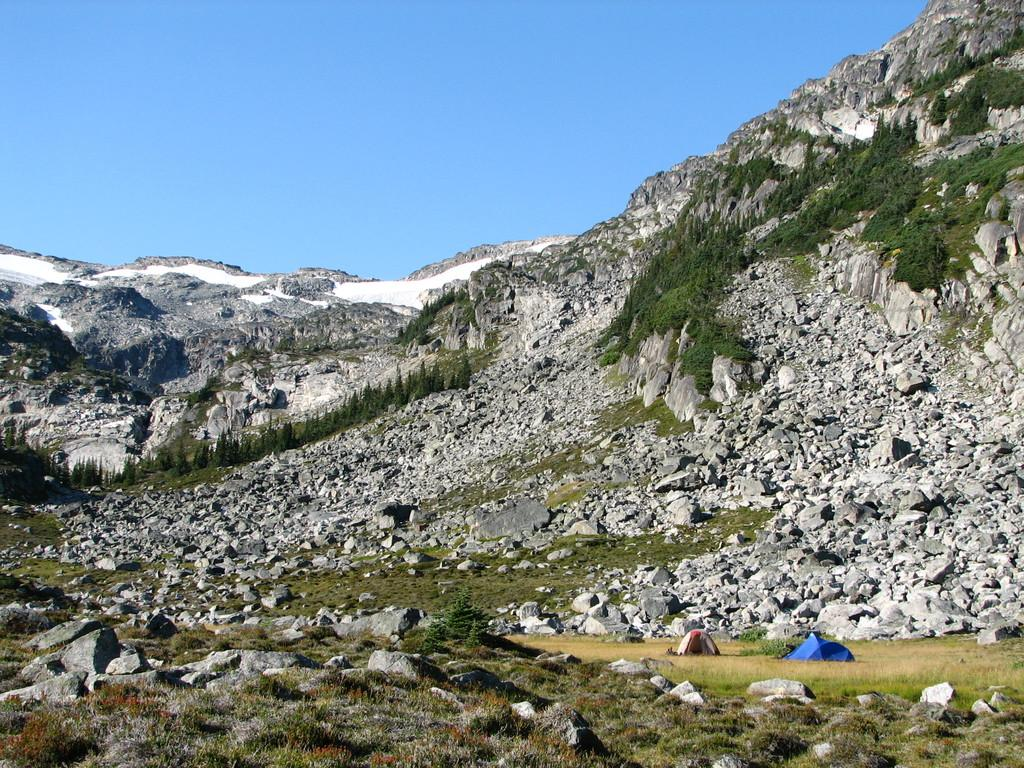What type of vegetation is present on the ground in the image? There is grass on the ground in the image. What can be seen in the center of the image? There are stones in the center of the image. What is visible in the background of the image? There are trees and mountains in the background of the image. Where is the wall located in the image? There is no wall present in the image. What type of animals can be seen in the zoo in the image? There is no zoo present in the image. 